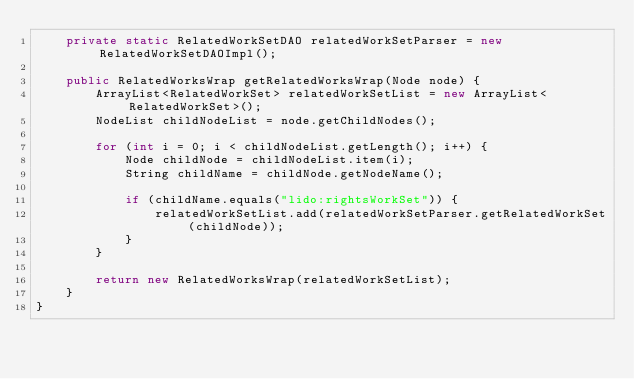<code> <loc_0><loc_0><loc_500><loc_500><_Java_>    private static RelatedWorkSetDAO relatedWorkSetParser = new RelatedWorkSetDAOImpl();

    public RelatedWorksWrap getRelatedWorksWrap(Node node) {
        ArrayList<RelatedWorkSet> relatedWorkSetList = new ArrayList<RelatedWorkSet>();
        NodeList childNodeList = node.getChildNodes();

        for (int i = 0; i < childNodeList.getLength(); i++) {
            Node childNode = childNodeList.item(i);
            String childName = childNode.getNodeName();

            if (childName.equals("lido:rightsWorkSet")) {
                relatedWorkSetList.add(relatedWorkSetParser.getRelatedWorkSet(childNode));
            }
        }

        return new RelatedWorksWrap(relatedWorkSetList);
    }
}
</code> 